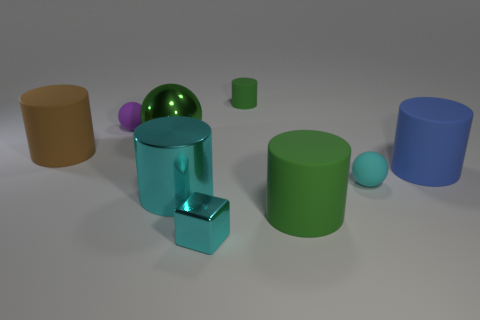Subtract 2 cylinders. How many cylinders are left? 3 Subtract all big green cylinders. How many cylinders are left? 4 Subtract all blue cylinders. How many cylinders are left? 4 Subtract all red cylinders. Subtract all gray spheres. How many cylinders are left? 5 Add 1 rubber blocks. How many objects exist? 10 Subtract all cylinders. How many objects are left? 4 Subtract all blue things. Subtract all small red rubber objects. How many objects are left? 8 Add 8 green metallic spheres. How many green metallic spheres are left? 9 Add 5 cyan cylinders. How many cyan cylinders exist? 6 Subtract 0 purple cubes. How many objects are left? 9 